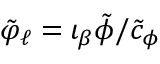Convert formula to latex. <formula><loc_0><loc_0><loc_500><loc_500>\tilde { \varphi } _ { \ell } = \iota _ { \beta } \tilde { \phi } / \tilde { c } _ { \phi }</formula> 